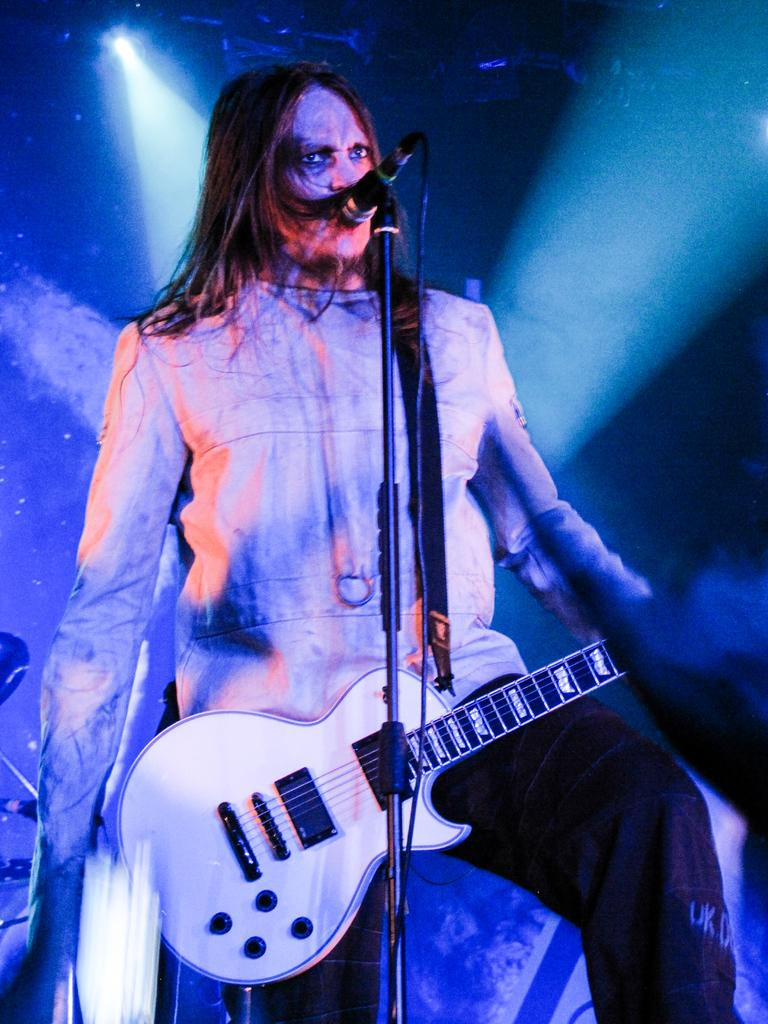Who or what is present in the image? There is a person in the image. What is the person doing in the image? The person is standing in the image. What object is the person holding in the image? The person is holding a guitar in the image. What equipment is visible in the image related to sound? There is a microphone and a microphone stand in the image. What type of picture is hanging on the wall in the image? There is no mention of a picture hanging on the wall in the image. What kind of jam is the person eating while playing the guitar? There is no jam or eating activity depicted in the image; the person is holding a guitar and standing. 